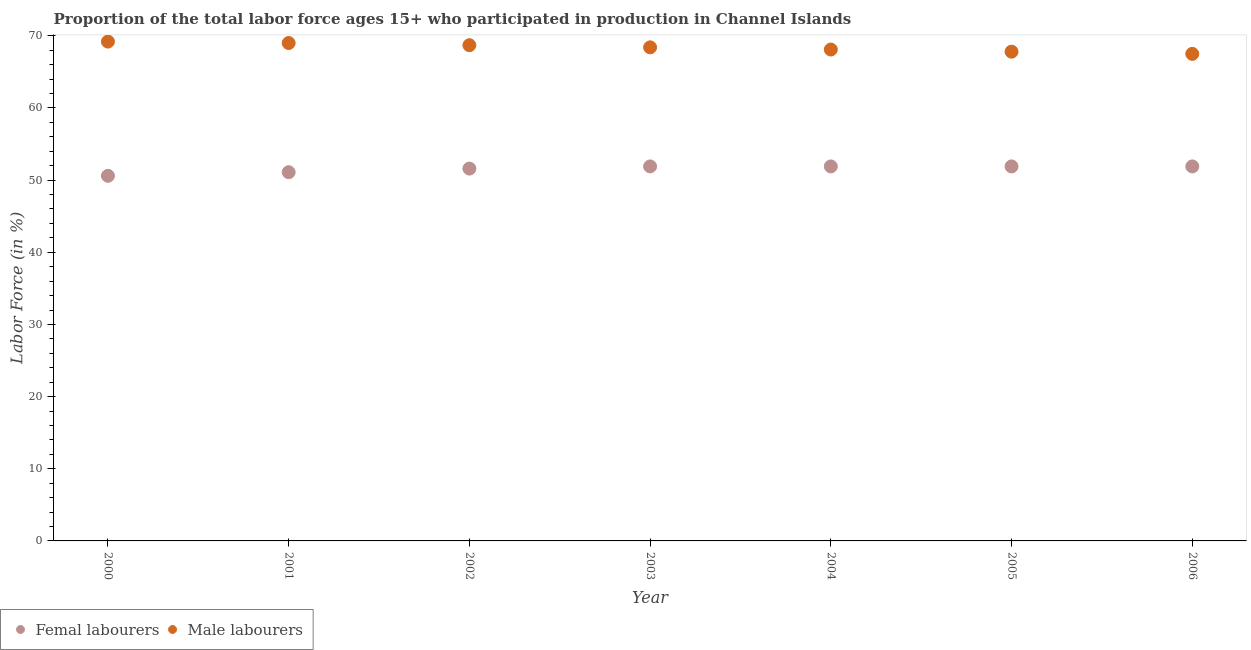Is the number of dotlines equal to the number of legend labels?
Ensure brevity in your answer.  Yes. What is the percentage of female labor force in 2002?
Your response must be concise. 51.6. Across all years, what is the maximum percentage of male labour force?
Make the answer very short. 69.2. Across all years, what is the minimum percentage of male labour force?
Offer a terse response. 67.5. What is the total percentage of male labour force in the graph?
Ensure brevity in your answer.  478.7. What is the difference between the percentage of female labor force in 2004 and that in 2006?
Offer a very short reply. 0. What is the difference between the percentage of female labor force in 2001 and the percentage of male labour force in 2005?
Provide a short and direct response. -16.7. What is the average percentage of male labour force per year?
Give a very brief answer. 68.39. In the year 2006, what is the difference between the percentage of female labor force and percentage of male labour force?
Provide a succinct answer. -15.6. In how many years, is the percentage of male labour force greater than 56 %?
Your response must be concise. 7. What is the ratio of the percentage of male labour force in 2002 to that in 2003?
Provide a short and direct response. 1. Is the percentage of male labour force in 2003 less than that in 2006?
Provide a succinct answer. No. Is the difference between the percentage of female labor force in 2002 and 2005 greater than the difference between the percentage of male labour force in 2002 and 2005?
Offer a terse response. No. What is the difference between the highest and the second highest percentage of male labour force?
Make the answer very short. 0.2. What is the difference between the highest and the lowest percentage of male labour force?
Your response must be concise. 1.7. In how many years, is the percentage of female labor force greater than the average percentage of female labor force taken over all years?
Provide a short and direct response. 5. Is the sum of the percentage of male labour force in 2001 and 2002 greater than the maximum percentage of female labor force across all years?
Make the answer very short. Yes. Does the percentage of male labour force monotonically increase over the years?
Offer a very short reply. No. Is the percentage of female labor force strictly greater than the percentage of male labour force over the years?
Your response must be concise. No. What is the difference between two consecutive major ticks on the Y-axis?
Give a very brief answer. 10. Are the values on the major ticks of Y-axis written in scientific E-notation?
Your answer should be very brief. No. What is the title of the graph?
Ensure brevity in your answer.  Proportion of the total labor force ages 15+ who participated in production in Channel Islands. What is the label or title of the X-axis?
Provide a succinct answer. Year. What is the Labor Force (in %) in Femal labourers in 2000?
Make the answer very short. 50.6. What is the Labor Force (in %) of Male labourers in 2000?
Make the answer very short. 69.2. What is the Labor Force (in %) in Femal labourers in 2001?
Offer a terse response. 51.1. What is the Labor Force (in %) of Femal labourers in 2002?
Provide a short and direct response. 51.6. What is the Labor Force (in %) of Male labourers in 2002?
Offer a terse response. 68.7. What is the Labor Force (in %) in Femal labourers in 2003?
Your response must be concise. 51.9. What is the Labor Force (in %) in Male labourers in 2003?
Your answer should be compact. 68.4. What is the Labor Force (in %) of Femal labourers in 2004?
Your response must be concise. 51.9. What is the Labor Force (in %) of Male labourers in 2004?
Provide a short and direct response. 68.1. What is the Labor Force (in %) of Femal labourers in 2005?
Offer a terse response. 51.9. What is the Labor Force (in %) of Male labourers in 2005?
Keep it short and to the point. 67.8. What is the Labor Force (in %) of Femal labourers in 2006?
Your response must be concise. 51.9. What is the Labor Force (in %) in Male labourers in 2006?
Your response must be concise. 67.5. Across all years, what is the maximum Labor Force (in %) of Femal labourers?
Ensure brevity in your answer.  51.9. Across all years, what is the maximum Labor Force (in %) of Male labourers?
Provide a short and direct response. 69.2. Across all years, what is the minimum Labor Force (in %) of Femal labourers?
Offer a terse response. 50.6. Across all years, what is the minimum Labor Force (in %) of Male labourers?
Your answer should be compact. 67.5. What is the total Labor Force (in %) of Femal labourers in the graph?
Keep it short and to the point. 360.9. What is the total Labor Force (in %) of Male labourers in the graph?
Make the answer very short. 478.7. What is the difference between the Labor Force (in %) in Male labourers in 2000 and that in 2001?
Provide a short and direct response. 0.2. What is the difference between the Labor Force (in %) of Femal labourers in 2000 and that in 2002?
Give a very brief answer. -1. What is the difference between the Labor Force (in %) in Male labourers in 2000 and that in 2002?
Offer a terse response. 0.5. What is the difference between the Labor Force (in %) in Male labourers in 2000 and that in 2003?
Keep it short and to the point. 0.8. What is the difference between the Labor Force (in %) of Femal labourers in 2000 and that in 2004?
Keep it short and to the point. -1.3. What is the difference between the Labor Force (in %) of Male labourers in 2000 and that in 2004?
Provide a succinct answer. 1.1. What is the difference between the Labor Force (in %) in Male labourers in 2000 and that in 2005?
Offer a terse response. 1.4. What is the difference between the Labor Force (in %) of Femal labourers in 2000 and that in 2006?
Offer a terse response. -1.3. What is the difference between the Labor Force (in %) of Male labourers in 2000 and that in 2006?
Your response must be concise. 1.7. What is the difference between the Labor Force (in %) in Male labourers in 2001 and that in 2002?
Provide a short and direct response. 0.3. What is the difference between the Labor Force (in %) of Femal labourers in 2001 and that in 2004?
Give a very brief answer. -0.8. What is the difference between the Labor Force (in %) in Male labourers in 2001 and that in 2004?
Ensure brevity in your answer.  0.9. What is the difference between the Labor Force (in %) of Femal labourers in 2001 and that in 2006?
Provide a short and direct response. -0.8. What is the difference between the Labor Force (in %) of Male labourers in 2001 and that in 2006?
Offer a terse response. 1.5. What is the difference between the Labor Force (in %) of Femal labourers in 2002 and that in 2003?
Keep it short and to the point. -0.3. What is the difference between the Labor Force (in %) in Femal labourers in 2002 and that in 2004?
Provide a succinct answer. -0.3. What is the difference between the Labor Force (in %) of Male labourers in 2002 and that in 2005?
Offer a terse response. 0.9. What is the difference between the Labor Force (in %) in Femal labourers in 2002 and that in 2006?
Keep it short and to the point. -0.3. What is the difference between the Labor Force (in %) in Femal labourers in 2003 and that in 2005?
Offer a very short reply. 0. What is the difference between the Labor Force (in %) of Male labourers in 2003 and that in 2006?
Your response must be concise. 0.9. What is the difference between the Labor Force (in %) in Femal labourers in 2004 and that in 2005?
Your response must be concise. 0. What is the difference between the Labor Force (in %) of Femal labourers in 2004 and that in 2006?
Keep it short and to the point. 0. What is the difference between the Labor Force (in %) of Femal labourers in 2005 and that in 2006?
Offer a terse response. 0. What is the difference between the Labor Force (in %) in Femal labourers in 2000 and the Labor Force (in %) in Male labourers in 2001?
Your answer should be very brief. -18.4. What is the difference between the Labor Force (in %) of Femal labourers in 2000 and the Labor Force (in %) of Male labourers in 2002?
Provide a succinct answer. -18.1. What is the difference between the Labor Force (in %) of Femal labourers in 2000 and the Labor Force (in %) of Male labourers in 2003?
Provide a short and direct response. -17.8. What is the difference between the Labor Force (in %) in Femal labourers in 2000 and the Labor Force (in %) in Male labourers in 2004?
Offer a terse response. -17.5. What is the difference between the Labor Force (in %) of Femal labourers in 2000 and the Labor Force (in %) of Male labourers in 2005?
Your answer should be very brief. -17.2. What is the difference between the Labor Force (in %) of Femal labourers in 2000 and the Labor Force (in %) of Male labourers in 2006?
Provide a short and direct response. -16.9. What is the difference between the Labor Force (in %) in Femal labourers in 2001 and the Labor Force (in %) in Male labourers in 2002?
Offer a very short reply. -17.6. What is the difference between the Labor Force (in %) in Femal labourers in 2001 and the Labor Force (in %) in Male labourers in 2003?
Make the answer very short. -17.3. What is the difference between the Labor Force (in %) in Femal labourers in 2001 and the Labor Force (in %) in Male labourers in 2005?
Your response must be concise. -16.7. What is the difference between the Labor Force (in %) of Femal labourers in 2001 and the Labor Force (in %) of Male labourers in 2006?
Your answer should be very brief. -16.4. What is the difference between the Labor Force (in %) of Femal labourers in 2002 and the Labor Force (in %) of Male labourers in 2003?
Ensure brevity in your answer.  -16.8. What is the difference between the Labor Force (in %) of Femal labourers in 2002 and the Labor Force (in %) of Male labourers in 2004?
Give a very brief answer. -16.5. What is the difference between the Labor Force (in %) of Femal labourers in 2002 and the Labor Force (in %) of Male labourers in 2005?
Offer a terse response. -16.2. What is the difference between the Labor Force (in %) in Femal labourers in 2002 and the Labor Force (in %) in Male labourers in 2006?
Give a very brief answer. -15.9. What is the difference between the Labor Force (in %) of Femal labourers in 2003 and the Labor Force (in %) of Male labourers in 2004?
Your response must be concise. -16.2. What is the difference between the Labor Force (in %) of Femal labourers in 2003 and the Labor Force (in %) of Male labourers in 2005?
Ensure brevity in your answer.  -15.9. What is the difference between the Labor Force (in %) of Femal labourers in 2003 and the Labor Force (in %) of Male labourers in 2006?
Keep it short and to the point. -15.6. What is the difference between the Labor Force (in %) of Femal labourers in 2004 and the Labor Force (in %) of Male labourers in 2005?
Provide a succinct answer. -15.9. What is the difference between the Labor Force (in %) of Femal labourers in 2004 and the Labor Force (in %) of Male labourers in 2006?
Offer a very short reply. -15.6. What is the difference between the Labor Force (in %) in Femal labourers in 2005 and the Labor Force (in %) in Male labourers in 2006?
Give a very brief answer. -15.6. What is the average Labor Force (in %) in Femal labourers per year?
Keep it short and to the point. 51.56. What is the average Labor Force (in %) in Male labourers per year?
Make the answer very short. 68.39. In the year 2000, what is the difference between the Labor Force (in %) in Femal labourers and Labor Force (in %) in Male labourers?
Provide a short and direct response. -18.6. In the year 2001, what is the difference between the Labor Force (in %) in Femal labourers and Labor Force (in %) in Male labourers?
Provide a short and direct response. -17.9. In the year 2002, what is the difference between the Labor Force (in %) in Femal labourers and Labor Force (in %) in Male labourers?
Offer a terse response. -17.1. In the year 2003, what is the difference between the Labor Force (in %) in Femal labourers and Labor Force (in %) in Male labourers?
Provide a short and direct response. -16.5. In the year 2004, what is the difference between the Labor Force (in %) in Femal labourers and Labor Force (in %) in Male labourers?
Your response must be concise. -16.2. In the year 2005, what is the difference between the Labor Force (in %) of Femal labourers and Labor Force (in %) of Male labourers?
Your answer should be very brief. -15.9. In the year 2006, what is the difference between the Labor Force (in %) of Femal labourers and Labor Force (in %) of Male labourers?
Offer a very short reply. -15.6. What is the ratio of the Labor Force (in %) of Femal labourers in 2000 to that in 2001?
Offer a very short reply. 0.99. What is the ratio of the Labor Force (in %) in Male labourers in 2000 to that in 2001?
Provide a short and direct response. 1. What is the ratio of the Labor Force (in %) in Femal labourers in 2000 to that in 2002?
Offer a terse response. 0.98. What is the ratio of the Labor Force (in %) of Male labourers in 2000 to that in 2002?
Provide a succinct answer. 1.01. What is the ratio of the Labor Force (in %) in Male labourers in 2000 to that in 2003?
Your answer should be compact. 1.01. What is the ratio of the Labor Force (in %) in Male labourers in 2000 to that in 2004?
Make the answer very short. 1.02. What is the ratio of the Labor Force (in %) of Femal labourers in 2000 to that in 2005?
Ensure brevity in your answer.  0.97. What is the ratio of the Labor Force (in %) in Male labourers in 2000 to that in 2005?
Ensure brevity in your answer.  1.02. What is the ratio of the Labor Force (in %) of Male labourers in 2000 to that in 2006?
Make the answer very short. 1.03. What is the ratio of the Labor Force (in %) in Femal labourers in 2001 to that in 2002?
Give a very brief answer. 0.99. What is the ratio of the Labor Force (in %) of Male labourers in 2001 to that in 2002?
Your answer should be compact. 1. What is the ratio of the Labor Force (in %) of Femal labourers in 2001 to that in 2003?
Offer a terse response. 0.98. What is the ratio of the Labor Force (in %) of Male labourers in 2001 to that in 2003?
Your response must be concise. 1.01. What is the ratio of the Labor Force (in %) in Femal labourers in 2001 to that in 2004?
Provide a short and direct response. 0.98. What is the ratio of the Labor Force (in %) in Male labourers in 2001 to that in 2004?
Offer a terse response. 1.01. What is the ratio of the Labor Force (in %) of Femal labourers in 2001 to that in 2005?
Keep it short and to the point. 0.98. What is the ratio of the Labor Force (in %) of Male labourers in 2001 to that in 2005?
Ensure brevity in your answer.  1.02. What is the ratio of the Labor Force (in %) of Femal labourers in 2001 to that in 2006?
Provide a short and direct response. 0.98. What is the ratio of the Labor Force (in %) in Male labourers in 2001 to that in 2006?
Give a very brief answer. 1.02. What is the ratio of the Labor Force (in %) in Male labourers in 2002 to that in 2004?
Offer a very short reply. 1.01. What is the ratio of the Labor Force (in %) in Male labourers in 2002 to that in 2005?
Your answer should be compact. 1.01. What is the ratio of the Labor Force (in %) in Femal labourers in 2002 to that in 2006?
Make the answer very short. 0.99. What is the ratio of the Labor Force (in %) of Male labourers in 2002 to that in 2006?
Make the answer very short. 1.02. What is the ratio of the Labor Force (in %) of Femal labourers in 2003 to that in 2004?
Give a very brief answer. 1. What is the ratio of the Labor Force (in %) of Male labourers in 2003 to that in 2004?
Give a very brief answer. 1. What is the ratio of the Labor Force (in %) of Male labourers in 2003 to that in 2005?
Keep it short and to the point. 1.01. What is the ratio of the Labor Force (in %) of Femal labourers in 2003 to that in 2006?
Make the answer very short. 1. What is the ratio of the Labor Force (in %) in Male labourers in 2003 to that in 2006?
Offer a terse response. 1.01. What is the ratio of the Labor Force (in %) in Femal labourers in 2004 to that in 2005?
Ensure brevity in your answer.  1. What is the ratio of the Labor Force (in %) of Male labourers in 2004 to that in 2006?
Your answer should be very brief. 1.01. What is the ratio of the Labor Force (in %) in Male labourers in 2005 to that in 2006?
Ensure brevity in your answer.  1. What is the difference between the highest and the second highest Labor Force (in %) of Femal labourers?
Your response must be concise. 0. What is the difference between the highest and the second highest Labor Force (in %) of Male labourers?
Offer a terse response. 0.2. What is the difference between the highest and the lowest Labor Force (in %) of Femal labourers?
Make the answer very short. 1.3. What is the difference between the highest and the lowest Labor Force (in %) in Male labourers?
Keep it short and to the point. 1.7. 